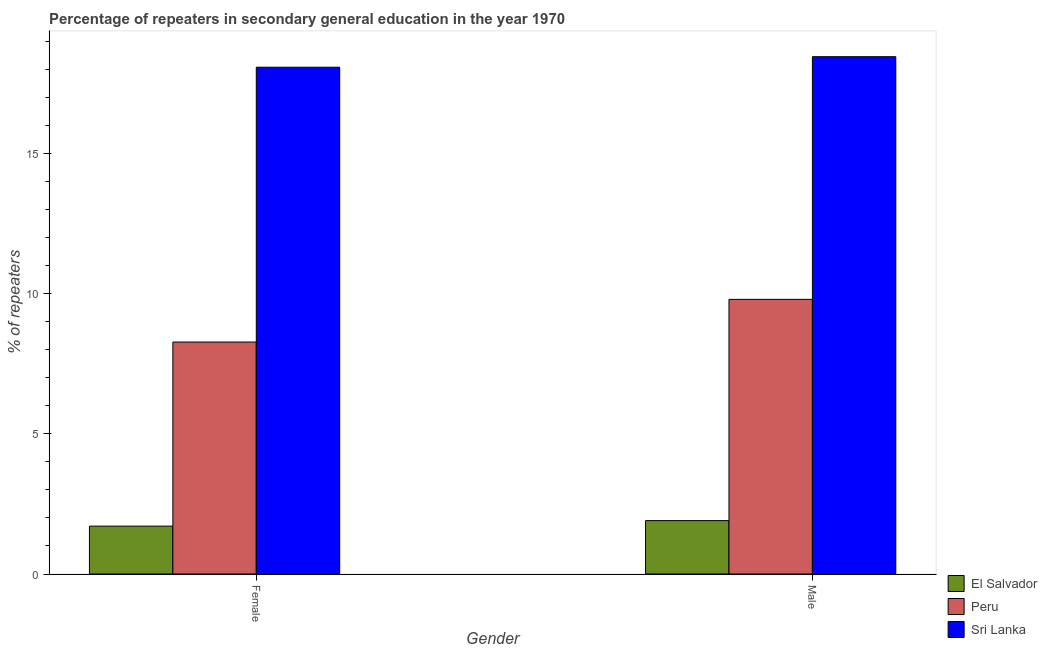How many different coloured bars are there?
Give a very brief answer. 3. Are the number of bars per tick equal to the number of legend labels?
Provide a short and direct response. Yes. How many bars are there on the 1st tick from the right?
Ensure brevity in your answer.  3. What is the label of the 2nd group of bars from the left?
Ensure brevity in your answer.  Male. What is the percentage of female repeaters in Peru?
Offer a very short reply. 8.28. Across all countries, what is the maximum percentage of female repeaters?
Ensure brevity in your answer.  18.09. Across all countries, what is the minimum percentage of female repeaters?
Make the answer very short. 1.71. In which country was the percentage of male repeaters maximum?
Provide a short and direct response. Sri Lanka. In which country was the percentage of male repeaters minimum?
Your answer should be very brief. El Salvador. What is the total percentage of male repeaters in the graph?
Your response must be concise. 30.17. What is the difference between the percentage of female repeaters in Peru and that in El Salvador?
Ensure brevity in your answer.  6.57. What is the difference between the percentage of female repeaters in Peru and the percentage of male repeaters in El Salvador?
Keep it short and to the point. 6.37. What is the average percentage of male repeaters per country?
Keep it short and to the point. 10.06. What is the difference between the percentage of female repeaters and percentage of male repeaters in El Salvador?
Provide a short and direct response. -0.2. What is the ratio of the percentage of female repeaters in Peru to that in Sri Lanka?
Offer a very short reply. 0.46. What does the 1st bar from the left in Male represents?
Your answer should be compact. El Salvador. How many bars are there?
Offer a very short reply. 6. Are all the bars in the graph horizontal?
Your answer should be compact. No. What is the difference between two consecutive major ticks on the Y-axis?
Your answer should be very brief. 5. Does the graph contain any zero values?
Your answer should be very brief. No. Does the graph contain grids?
Offer a terse response. No. Where does the legend appear in the graph?
Make the answer very short. Bottom right. How many legend labels are there?
Ensure brevity in your answer.  3. What is the title of the graph?
Keep it short and to the point. Percentage of repeaters in secondary general education in the year 1970. What is the label or title of the X-axis?
Your response must be concise. Gender. What is the label or title of the Y-axis?
Ensure brevity in your answer.  % of repeaters. What is the % of repeaters in El Salvador in Female?
Provide a short and direct response. 1.71. What is the % of repeaters in Peru in Female?
Your answer should be very brief. 8.28. What is the % of repeaters of Sri Lanka in Female?
Ensure brevity in your answer.  18.09. What is the % of repeaters of El Salvador in Male?
Keep it short and to the point. 1.91. What is the % of repeaters of Peru in Male?
Offer a very short reply. 9.8. What is the % of repeaters in Sri Lanka in Male?
Offer a very short reply. 18.46. Across all Gender, what is the maximum % of repeaters in El Salvador?
Keep it short and to the point. 1.91. Across all Gender, what is the maximum % of repeaters of Peru?
Make the answer very short. 9.8. Across all Gender, what is the maximum % of repeaters in Sri Lanka?
Provide a succinct answer. 18.46. Across all Gender, what is the minimum % of repeaters of El Salvador?
Give a very brief answer. 1.71. Across all Gender, what is the minimum % of repeaters in Peru?
Offer a very short reply. 8.28. Across all Gender, what is the minimum % of repeaters of Sri Lanka?
Give a very brief answer. 18.09. What is the total % of repeaters in El Salvador in the graph?
Make the answer very short. 3.61. What is the total % of repeaters of Peru in the graph?
Provide a succinct answer. 18.08. What is the total % of repeaters in Sri Lanka in the graph?
Give a very brief answer. 36.55. What is the difference between the % of repeaters in El Salvador in Female and that in Male?
Provide a succinct answer. -0.2. What is the difference between the % of repeaters in Peru in Female and that in Male?
Keep it short and to the point. -1.52. What is the difference between the % of repeaters of Sri Lanka in Female and that in Male?
Your response must be concise. -0.38. What is the difference between the % of repeaters of El Salvador in Female and the % of repeaters of Peru in Male?
Provide a succinct answer. -8.09. What is the difference between the % of repeaters of El Salvador in Female and the % of repeaters of Sri Lanka in Male?
Offer a very short reply. -16.76. What is the difference between the % of repeaters of Peru in Female and the % of repeaters of Sri Lanka in Male?
Keep it short and to the point. -10.18. What is the average % of repeaters in El Salvador per Gender?
Ensure brevity in your answer.  1.81. What is the average % of repeaters of Peru per Gender?
Offer a very short reply. 9.04. What is the average % of repeaters of Sri Lanka per Gender?
Make the answer very short. 18.28. What is the difference between the % of repeaters of El Salvador and % of repeaters of Peru in Female?
Offer a terse response. -6.57. What is the difference between the % of repeaters in El Salvador and % of repeaters in Sri Lanka in Female?
Keep it short and to the point. -16.38. What is the difference between the % of repeaters of Peru and % of repeaters of Sri Lanka in Female?
Provide a succinct answer. -9.81. What is the difference between the % of repeaters in El Salvador and % of repeaters in Peru in Male?
Your answer should be very brief. -7.9. What is the difference between the % of repeaters of El Salvador and % of repeaters of Sri Lanka in Male?
Provide a short and direct response. -16.56. What is the difference between the % of repeaters in Peru and % of repeaters in Sri Lanka in Male?
Your answer should be very brief. -8.66. What is the ratio of the % of repeaters in El Salvador in Female to that in Male?
Your response must be concise. 0.9. What is the ratio of the % of repeaters of Peru in Female to that in Male?
Give a very brief answer. 0.84. What is the ratio of the % of repeaters in Sri Lanka in Female to that in Male?
Keep it short and to the point. 0.98. What is the difference between the highest and the second highest % of repeaters in El Salvador?
Offer a terse response. 0.2. What is the difference between the highest and the second highest % of repeaters in Peru?
Offer a very short reply. 1.52. What is the difference between the highest and the second highest % of repeaters in Sri Lanka?
Ensure brevity in your answer.  0.38. What is the difference between the highest and the lowest % of repeaters of El Salvador?
Ensure brevity in your answer.  0.2. What is the difference between the highest and the lowest % of repeaters of Peru?
Make the answer very short. 1.52. What is the difference between the highest and the lowest % of repeaters of Sri Lanka?
Ensure brevity in your answer.  0.38. 